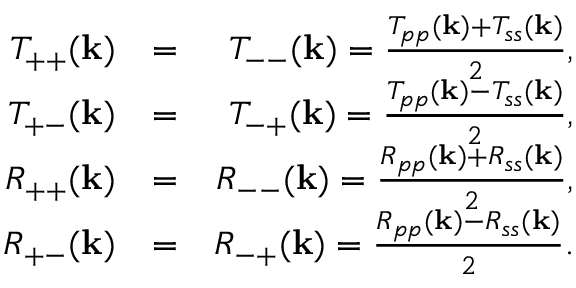<formula> <loc_0><loc_0><loc_500><loc_500>\begin{array} { r l r } { T _ { + + } ( { k } ) } & { = } & { T _ { - - } ( { k } ) = \frac { T _ { p p } ( { k } ) + T _ { s s } ( { k } ) } { 2 } , } \\ { T _ { + - } ( { k } ) } & { = } & { T _ { - + } ( { k } ) = \frac { T _ { p p } ( { k } ) - T _ { s s } ( { k } ) } { 2 } , } \\ { R _ { + + } ( { k } ) } & { = } & { R _ { - - } ( { k } ) = \frac { R _ { p p } ( { k } ) + R _ { s s } ( { k } ) } { 2 } , } \\ { R _ { + - } ( { k } ) } & { = } & { R _ { - + } ( { k } ) = \frac { R _ { p p } ( { k } ) - R _ { s s } ( { k } ) } { 2 } . } \end{array}</formula> 